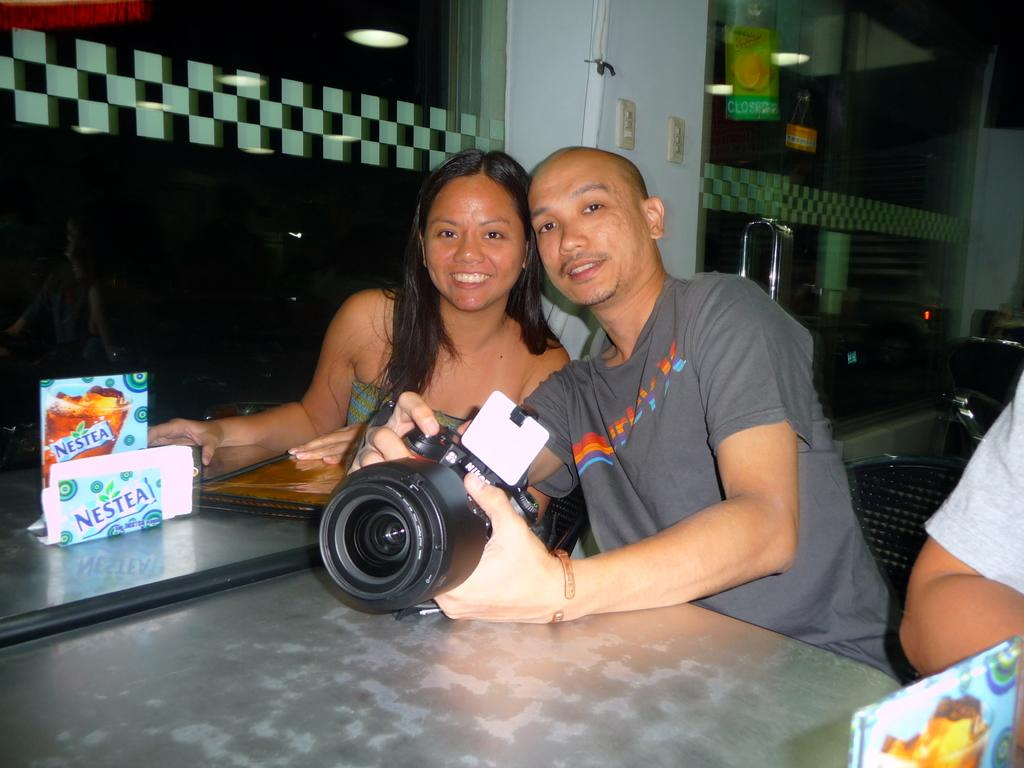How many people are in the image? There are two people in the image, a man and a woman. What are the man and woman doing in the image? The man and woman are sitting together. Can you describe what the man is holding in his hand? The man is holding a camera in his hand. What is in front of the man and woman? There is a table in front of them. What type of grain is being used to create the event in the image? There is no event or grain present in the image; it features a man and a woman sitting together with a table and a camera. What color is the yarn being used by the man in the image? There is no yarn present in the image; the man is holding a camera. 